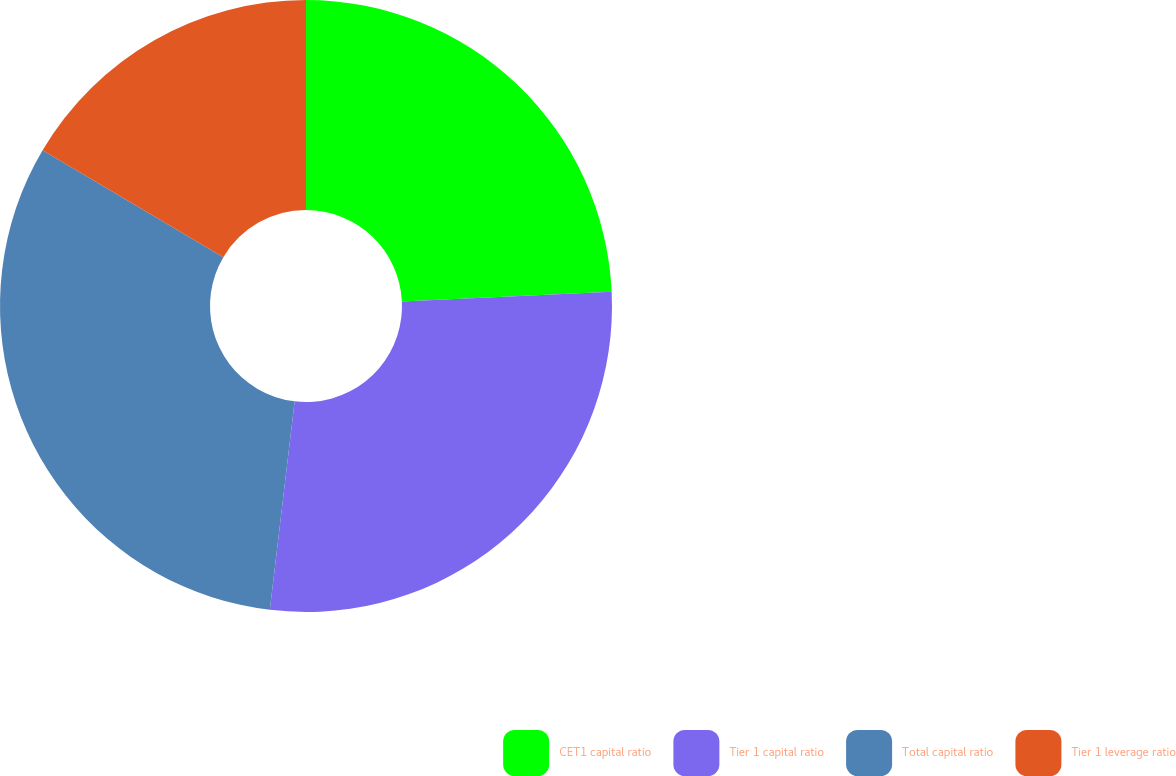Convert chart. <chart><loc_0><loc_0><loc_500><loc_500><pie_chart><fcel>CET1 capital ratio<fcel>Tier 1 capital ratio<fcel>Total capital ratio<fcel>Tier 1 leverage ratio<nl><fcel>24.25%<fcel>27.63%<fcel>31.61%<fcel>16.5%<nl></chart> 